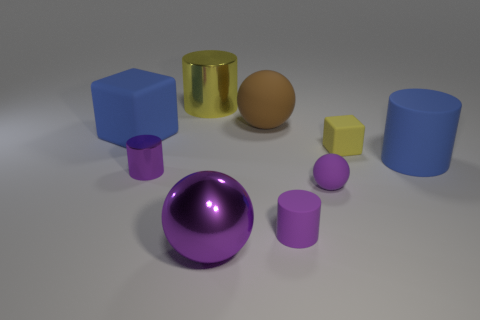The thing that is the same color as the small cube is what size?
Your answer should be very brief. Large. There is a rubber block left of the large sphere in front of the small rubber block; what number of metallic things are in front of it?
Your response must be concise. 2. There is a metal cylinder in front of the blue rubber cylinder; is its size the same as the purple cylinder that is right of the large purple thing?
Give a very brief answer. Yes. There is a large object on the right side of the yellow rubber block that is in front of the big brown ball; what is it made of?
Ensure brevity in your answer.  Rubber. How many things are big blue things that are on the right side of the yellow metal cylinder or red rubber objects?
Your response must be concise. 1. Are there the same number of large blue matte cylinders on the left side of the big yellow metal object and tiny purple rubber things left of the big blue cylinder?
Provide a succinct answer. No. What material is the large purple ball that is right of the thing left of the metallic cylinder in front of the blue cube?
Offer a terse response. Metal. There is a purple thing that is both behind the purple matte cylinder and on the left side of the small purple ball; what size is it?
Provide a short and direct response. Small. Is the shape of the small yellow rubber thing the same as the big yellow object?
Ensure brevity in your answer.  No. The tiny yellow thing that is made of the same material as the large brown thing is what shape?
Offer a very short reply. Cube. 